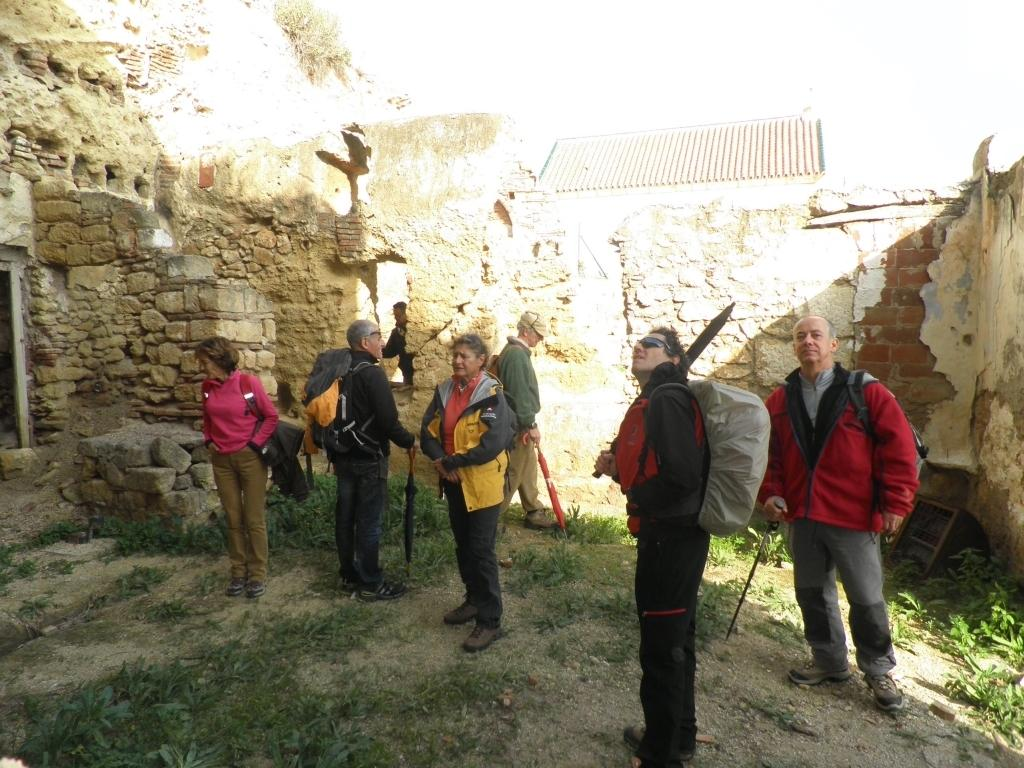What type of vegetation is present on the ground in the image? There is grass on the ground in the image. What can be seen in the center of the image? There are persons in the center of the image. What is visible in the background of the image? There is a wall in the background of the image. What type of fang can be seen in the image? There is no fang present in the image. Can you read the letter on the wall in the image? There is no letter visible on the wall in the image. 